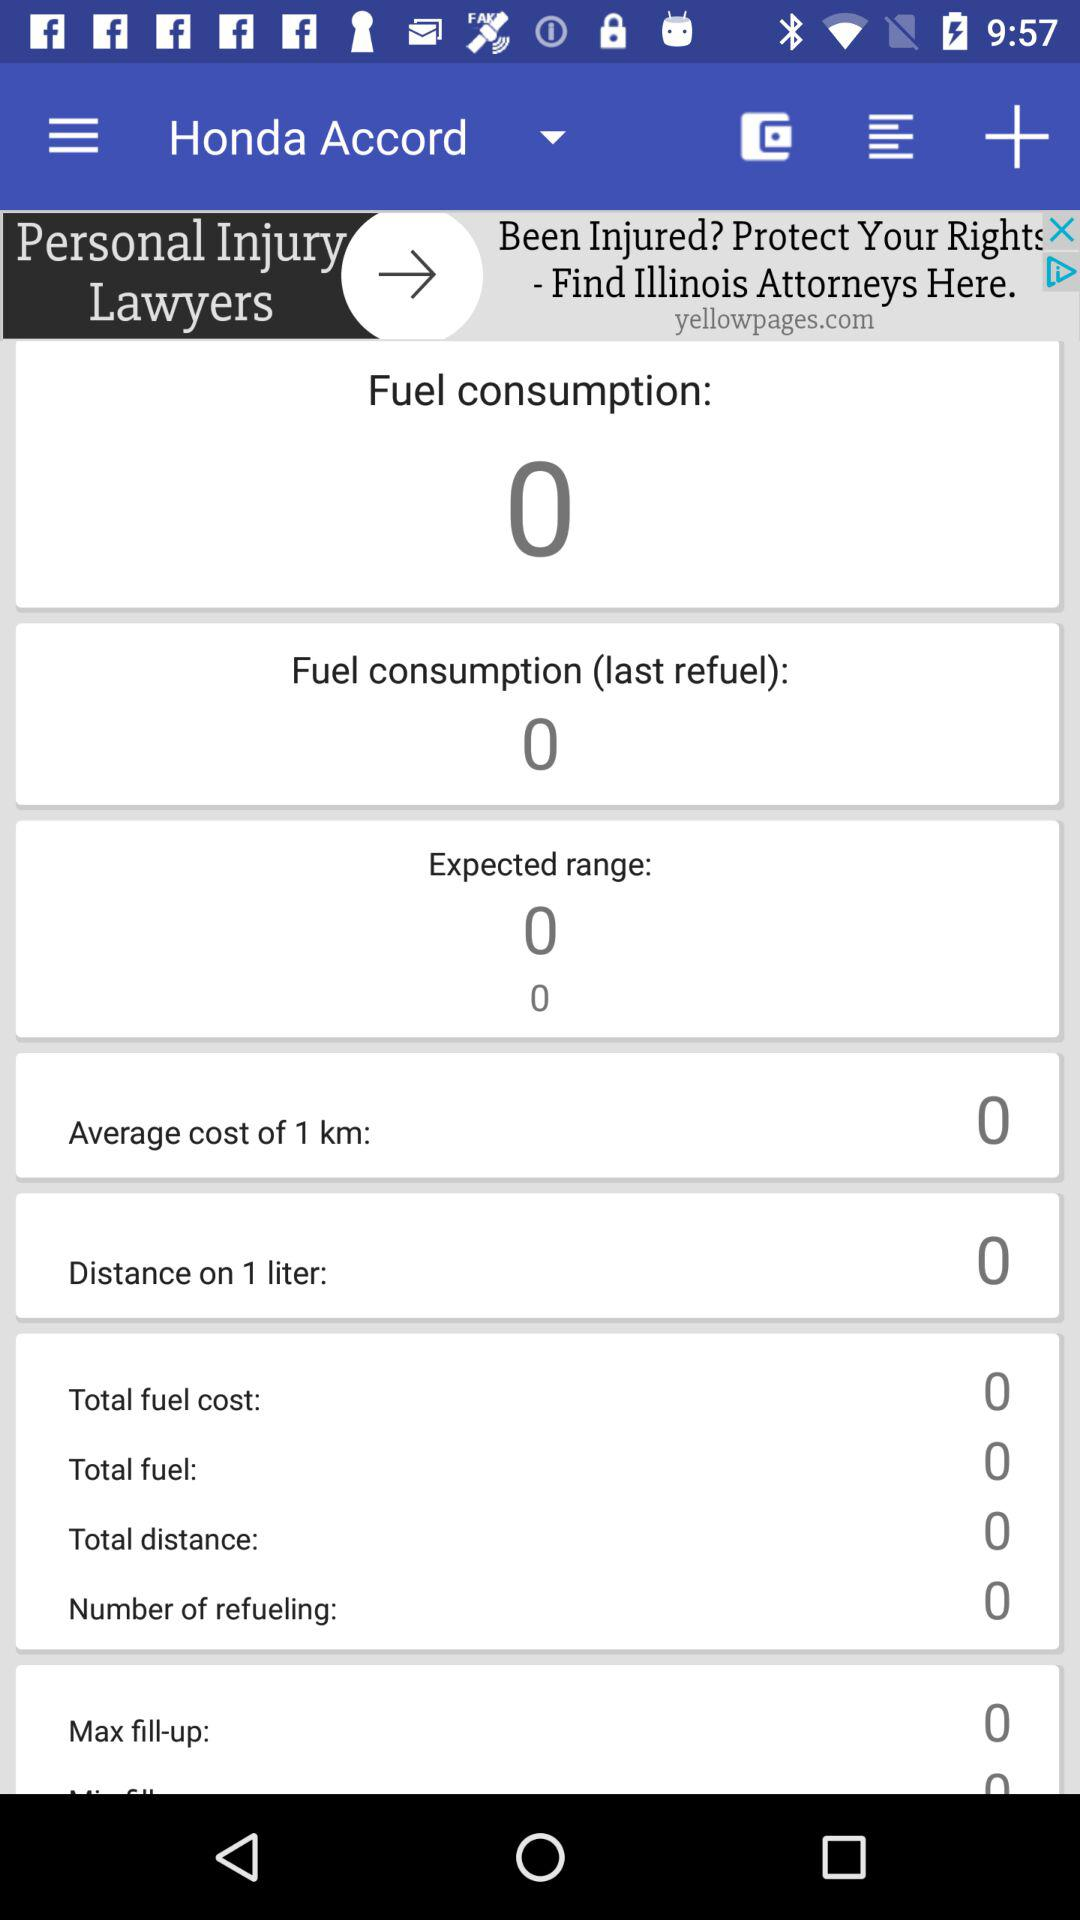What is the total distance? The total distance is 0. 